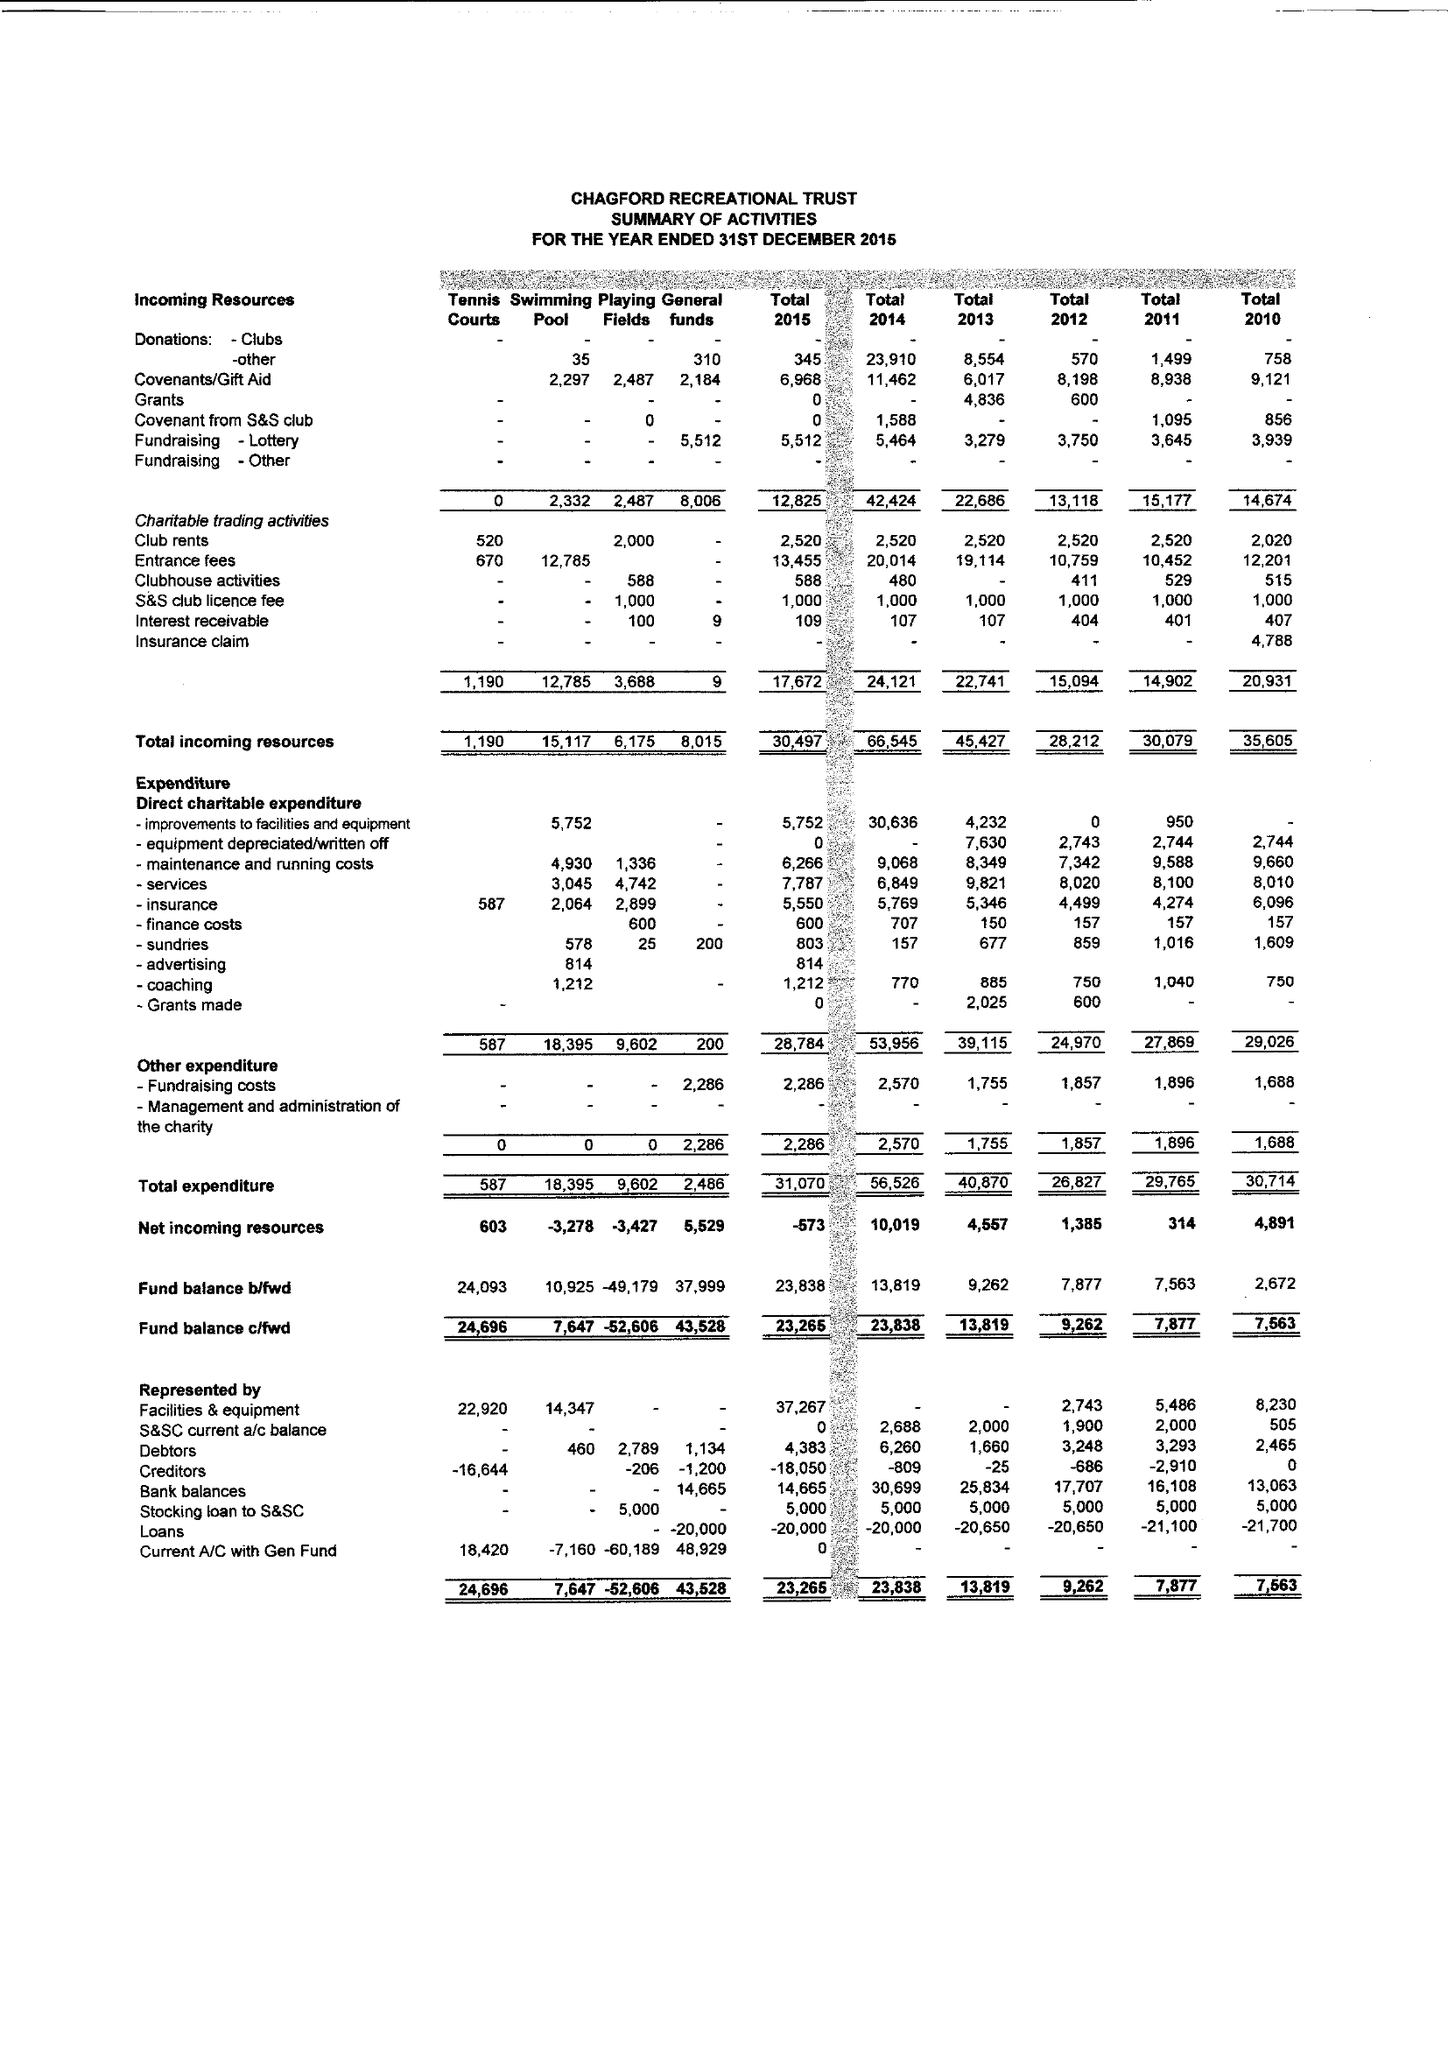What is the value for the income_annually_in_british_pounds?
Answer the question using a single word or phrase. 30497.00 